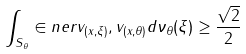<formula> <loc_0><loc_0><loc_500><loc_500>\int _ { S _ { \theta } } \in n e r { v _ { ( x , \xi ) } , v _ { ( x , \theta ) } } d \nu _ { \theta } ( \xi ) \geq \frac { \sqrt { 2 } } { 2 }</formula> 